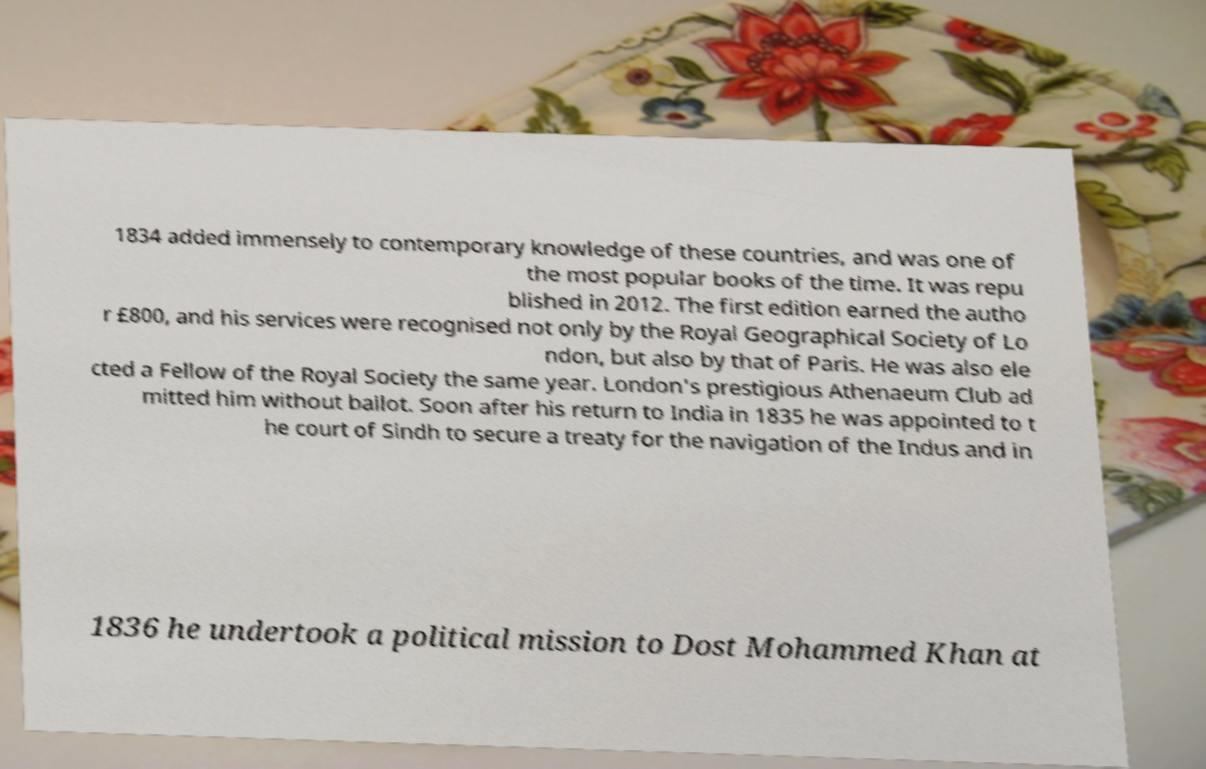Please identify and transcribe the text found in this image. 1834 added immensely to contemporary knowledge of these countries, and was one of the most popular books of the time. It was repu blished in 2012. The first edition earned the autho r £800, and his services were recognised not only by the Royal Geographical Society of Lo ndon, but also by that of Paris. He was also ele cted a Fellow of the Royal Society the same year. London's prestigious Athenaeum Club ad mitted him without ballot. Soon after his return to India in 1835 he was appointed to t he court of Sindh to secure a treaty for the navigation of the Indus and in 1836 he undertook a political mission to Dost Mohammed Khan at 